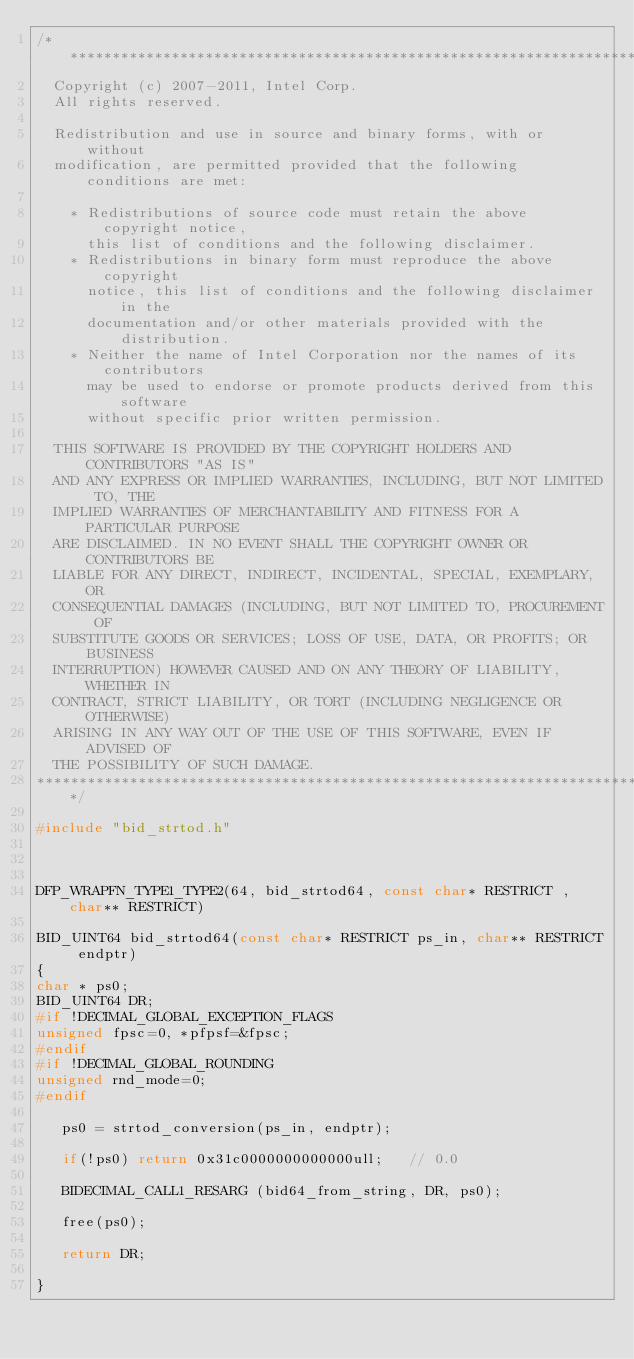Convert code to text. <code><loc_0><loc_0><loc_500><loc_500><_C_>/******************************************************************************
  Copyright (c) 2007-2011, Intel Corp.
  All rights reserved.

  Redistribution and use in source and binary forms, with or without 
  modification, are permitted provided that the following conditions are met:

    * Redistributions of source code must retain the above copyright notice, 
      this list of conditions and the following disclaimer.
    * Redistributions in binary form must reproduce the above copyright 
      notice, this list of conditions and the following disclaimer in the 
      documentation and/or other materials provided with the distribution.
    * Neither the name of Intel Corporation nor the names of its contributors 
      may be used to endorse or promote products derived from this software 
      without specific prior written permission.

  THIS SOFTWARE IS PROVIDED BY THE COPYRIGHT HOLDERS AND CONTRIBUTORS "AS IS"
  AND ANY EXPRESS OR IMPLIED WARRANTIES, INCLUDING, BUT NOT LIMITED TO, THE
  IMPLIED WARRANTIES OF MERCHANTABILITY AND FITNESS FOR A PARTICULAR PURPOSE
  ARE DISCLAIMED. IN NO EVENT SHALL THE COPYRIGHT OWNER OR CONTRIBUTORS BE
  LIABLE FOR ANY DIRECT, INDIRECT, INCIDENTAL, SPECIAL, EXEMPLARY, OR
  CONSEQUENTIAL DAMAGES (INCLUDING, BUT NOT LIMITED TO, PROCUREMENT OF
  SUBSTITUTE GOODS OR SERVICES; LOSS OF USE, DATA, OR PROFITS; OR BUSINESS
  INTERRUPTION) HOWEVER CAUSED AND ON ANY THEORY OF LIABILITY, WHETHER IN
  CONTRACT, STRICT LIABILITY, OR TORT (INCLUDING NEGLIGENCE OR OTHERWISE)
  ARISING IN ANY WAY OUT OF THE USE OF THIS SOFTWARE, EVEN IF ADVISED OF
  THE POSSIBILITY OF SUCH DAMAGE.
******************************************************************************/

#include "bid_strtod.h"



DFP_WRAPFN_TYPE1_TYPE2(64, bid_strtod64, const char* RESTRICT , char** RESTRICT)

BID_UINT64 bid_strtod64(const char* RESTRICT ps_in, char** RESTRICT endptr)
{
char * ps0;
BID_UINT64 DR;
#if !DECIMAL_GLOBAL_EXCEPTION_FLAGS
unsigned fpsc=0, *pfpsf=&fpsc;
#endif
#if !DECIMAL_GLOBAL_ROUNDING
unsigned rnd_mode=0;
#endif

   ps0 = strtod_conversion(ps_in, endptr);

   if(!ps0) return 0x31c0000000000000ull;   // 0.0

   BIDECIMAL_CALL1_RESARG (bid64_from_string, DR, ps0);

   free(ps0);

   return DR;

}



 
</code> 